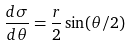Convert formula to latex. <formula><loc_0><loc_0><loc_500><loc_500>\frac { d \sigma } { d \theta } = \frac { r } { 2 } \sin ( \theta / 2 )</formula> 